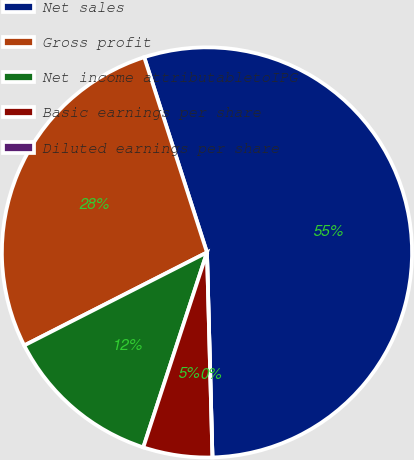Convert chart. <chart><loc_0><loc_0><loc_500><loc_500><pie_chart><fcel>Net sales<fcel>Gross profit<fcel>Net income attributabletoIPG<fcel>Basic earnings per share<fcel>Diluted earnings per share<nl><fcel>54.52%<fcel>27.54%<fcel>12.48%<fcel>5.45%<fcel>0.0%<nl></chart> 